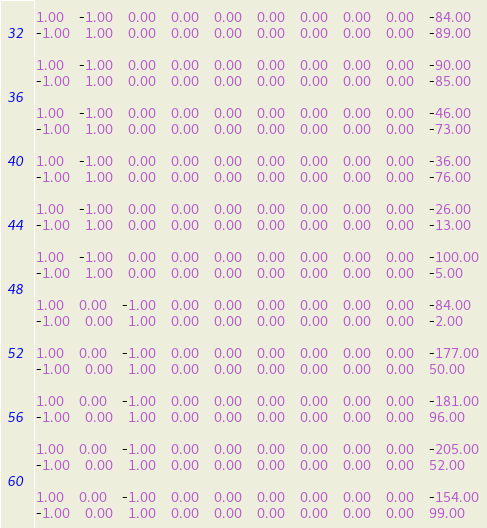Convert code to text. <code><loc_0><loc_0><loc_500><loc_500><_Matlab_>1.00	-1.00	0.00	0.00	0.00	0.00	0.00	0.00	0.00	-84.00
-1.00	1.00	0.00	0.00	0.00	0.00	0.00	0.00	0.00	-89.00

1.00	-1.00	0.00	0.00	0.00	0.00	0.00	0.00	0.00	-90.00
-1.00	1.00	0.00	0.00	0.00	0.00	0.00	0.00	0.00	-85.00

1.00	-1.00	0.00	0.00	0.00	0.00	0.00	0.00	0.00	-46.00
-1.00	1.00	0.00	0.00	0.00	0.00	0.00	0.00	0.00	-73.00

1.00	-1.00	0.00	0.00	0.00	0.00	0.00	0.00	0.00	-36.00
-1.00	1.00	0.00	0.00	0.00	0.00	0.00	0.00	0.00	-76.00

1.00	-1.00	0.00	0.00	0.00	0.00	0.00	0.00	0.00	-26.00
-1.00	1.00	0.00	0.00	0.00	0.00	0.00	0.00	0.00	-13.00

1.00	-1.00	0.00	0.00	0.00	0.00	0.00	0.00	0.00	-100.00
-1.00	1.00	0.00	0.00	0.00	0.00	0.00	0.00	0.00	-5.00

1.00	0.00	-1.00	0.00	0.00	0.00	0.00	0.00	0.00	-84.00
-1.00	0.00	1.00	0.00	0.00	0.00	0.00	0.00	0.00	-2.00

1.00	0.00	-1.00	0.00	0.00	0.00	0.00	0.00	0.00	-177.00
-1.00	0.00	1.00	0.00	0.00	0.00	0.00	0.00	0.00	50.00

1.00	0.00	-1.00	0.00	0.00	0.00	0.00	0.00	0.00	-181.00
-1.00	0.00	1.00	0.00	0.00	0.00	0.00	0.00	0.00	96.00

1.00	0.00	-1.00	0.00	0.00	0.00	0.00	0.00	0.00	-205.00
-1.00	0.00	1.00	0.00	0.00	0.00	0.00	0.00	0.00	52.00

1.00	0.00	-1.00	0.00	0.00	0.00	0.00	0.00	0.00	-154.00
-1.00	0.00	1.00	0.00	0.00	0.00	0.00	0.00	0.00	99.00
</code> 